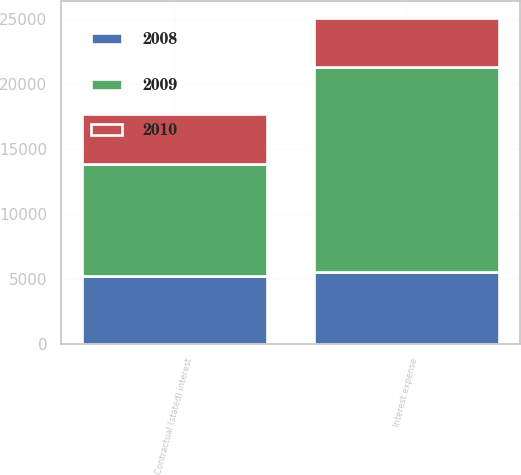<chart> <loc_0><loc_0><loc_500><loc_500><stacked_bar_chart><ecel><fcel>Contractual (stated) interest<fcel>Interest expense<nl><fcel>2010<fcel>3812<fcel>3812<nl><fcel>2008<fcel>5209<fcel>5510<nl><fcel>2009<fcel>8625<fcel>15764<nl></chart> 